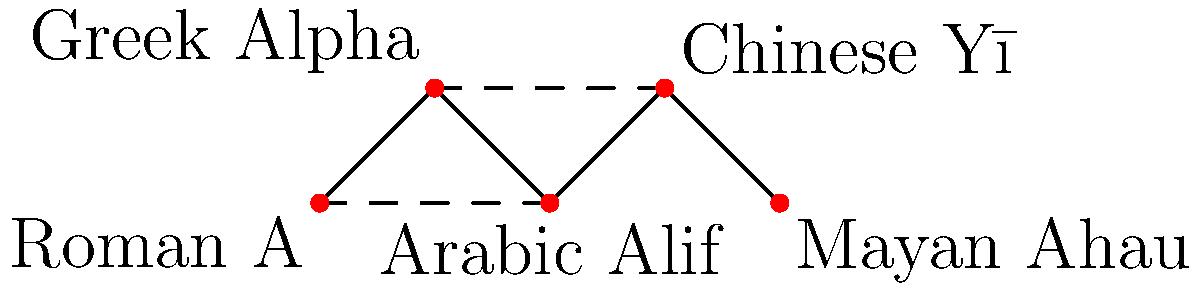In the given graph, nodes represent different letterforms across cultures, and edges indicate shared visual or structural characteristics. What is the minimum number of edges that need to be removed to disconnect the "Roman A" node from the "Mayan Ahau" node? To solve this problem, we need to analyze the graph and identify all possible paths between the "Roman A" node and the "Mayan Ahau" node. Then, we'll determine the minimum number of edges that need to be removed to disconnect these two nodes.

Step 1: Identify all paths between "Roman A" and "Mayan Ahau":
1. Roman A → Greek Alpha → Chinese Yī → Mayan Ahau
2. Roman A → Arabic Alif → Chinese Yī → Mayan Ahau
3. Roman A → Greek Alpha → Arabic Alif → Chinese Yī → Mayan Ahau

Step 2: Analyze the edges that appear in these paths:
- The edge between Arabic Alif and Chinese Yī appears in two paths.
- The edge between Chinese Yī and Mayan Ahau appears in all three paths.

Step 3: Determine the minimum number of edges to remove:
To disconnect "Roman A" from "Mayan Ahau", we need to remove at least two edges:
1. The edge between Chinese Yī and Mayan Ahau (which appears in all paths)
2. Either the edge between Roman A and Greek Alpha, or the edge between Roman A and Arabic Alif

By removing these two edges, we ensure that there is no path connecting "Roman A" to "Mayan Ahau".

Therefore, the minimum number of edges that need to be removed is 2.
Answer: 2 